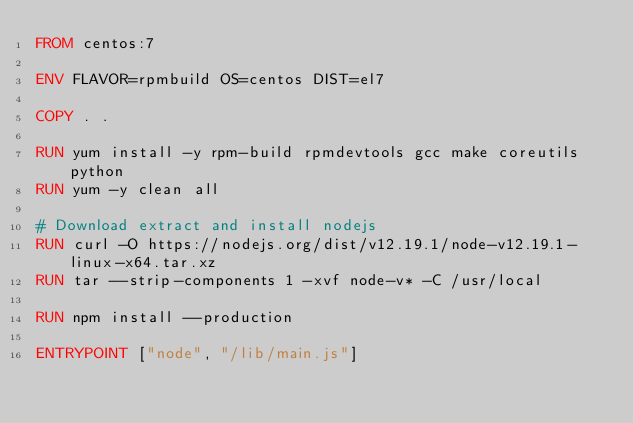Convert code to text. <code><loc_0><loc_0><loc_500><loc_500><_Dockerfile_>FROM centos:7

ENV FLAVOR=rpmbuild OS=centos DIST=el7

COPY . .

RUN yum install -y rpm-build rpmdevtools gcc make coreutils python
RUN yum -y clean all

# Download extract and install nodejs
RUN curl -O https://nodejs.org/dist/v12.19.1/node-v12.19.1-linux-x64.tar.xz
RUN tar --strip-components 1 -xvf node-v* -C /usr/local

RUN npm install --production

ENTRYPOINT ["node", "/lib/main.js"]</code> 